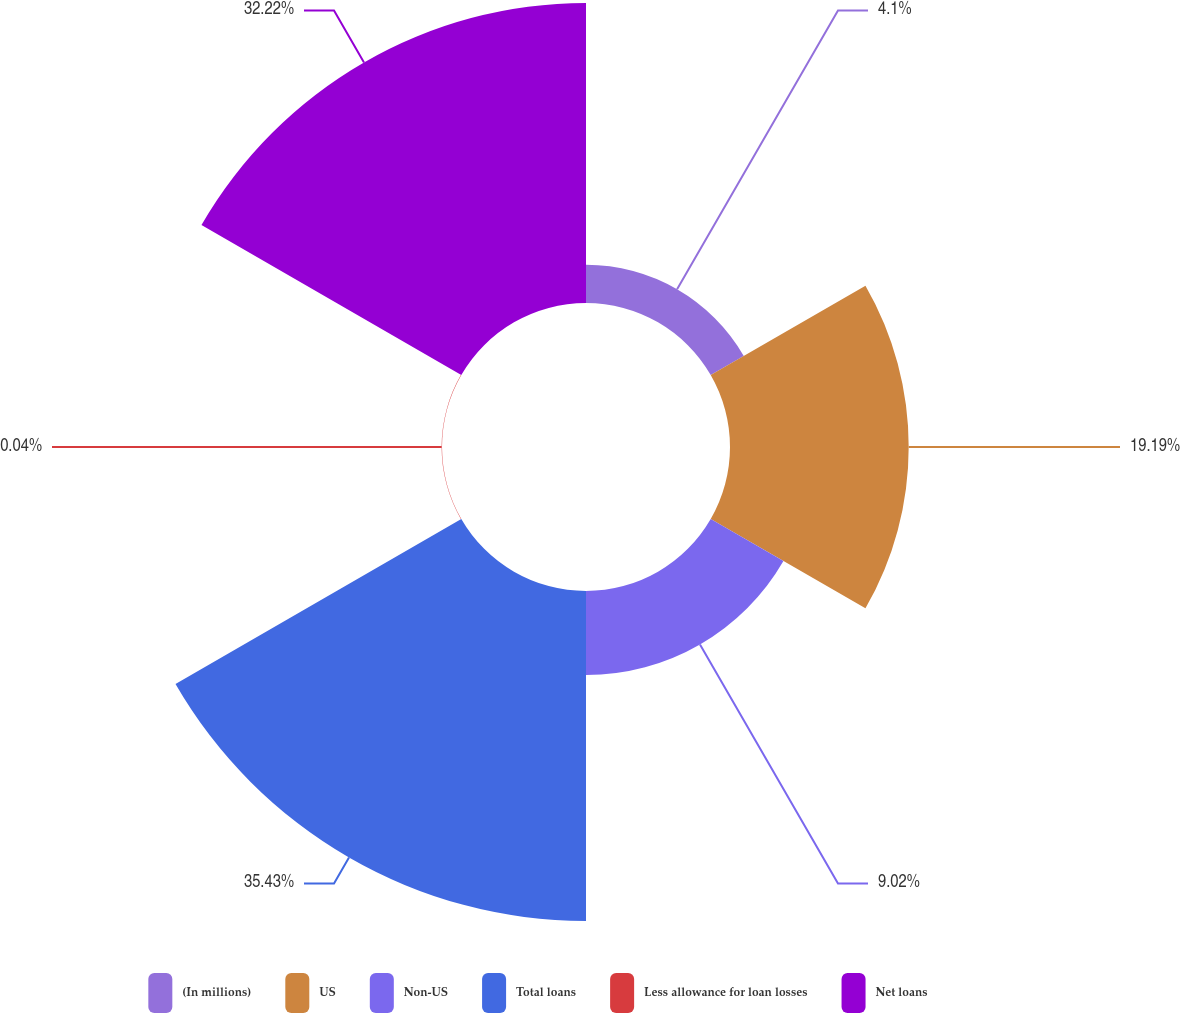Convert chart to OTSL. <chart><loc_0><loc_0><loc_500><loc_500><pie_chart><fcel>(In millions)<fcel>US<fcel>Non-US<fcel>Total loans<fcel>Less allowance for loan losses<fcel>Net loans<nl><fcel>4.1%<fcel>19.19%<fcel>9.02%<fcel>35.44%<fcel>0.04%<fcel>32.22%<nl></chart> 